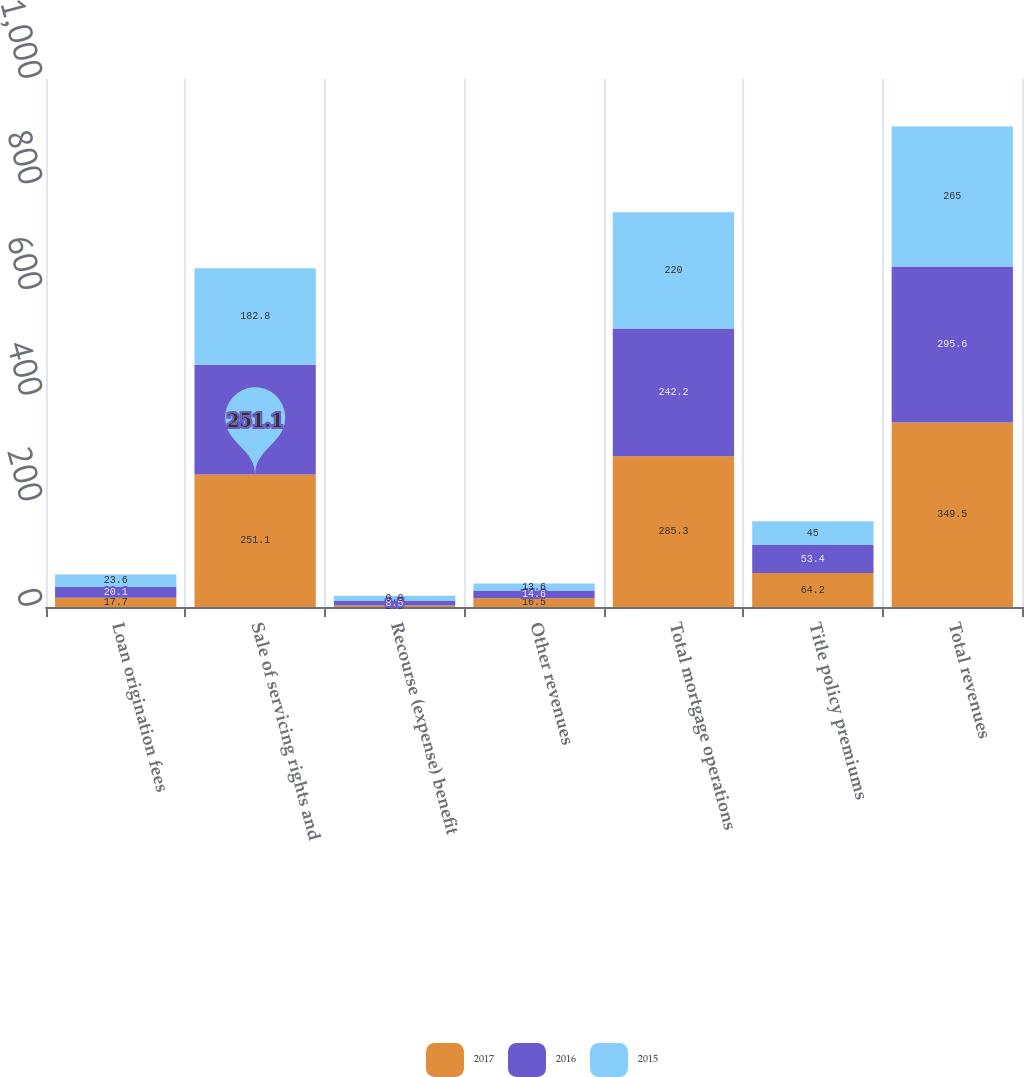<chart> <loc_0><loc_0><loc_500><loc_500><stacked_bar_chart><ecel><fcel>Loan origination fees<fcel>Sale of servicing rights and<fcel>Recourse (expense) benefit<fcel>Other revenues<fcel>Total mortgage operations<fcel>Title policy premiums<fcel>Total revenues<nl><fcel>2017<fcel>17.7<fcel>251.1<fcel>2.9<fcel>16.5<fcel>285.3<fcel>64.2<fcel>349.5<nl><fcel>2016<fcel>20.1<fcel>207.5<fcel>8.5<fcel>14.6<fcel>242.2<fcel>53.4<fcel>295.6<nl><fcel>2015<fcel>23.6<fcel>182.8<fcel>9.8<fcel>13.6<fcel>220<fcel>45<fcel>265<nl></chart> 